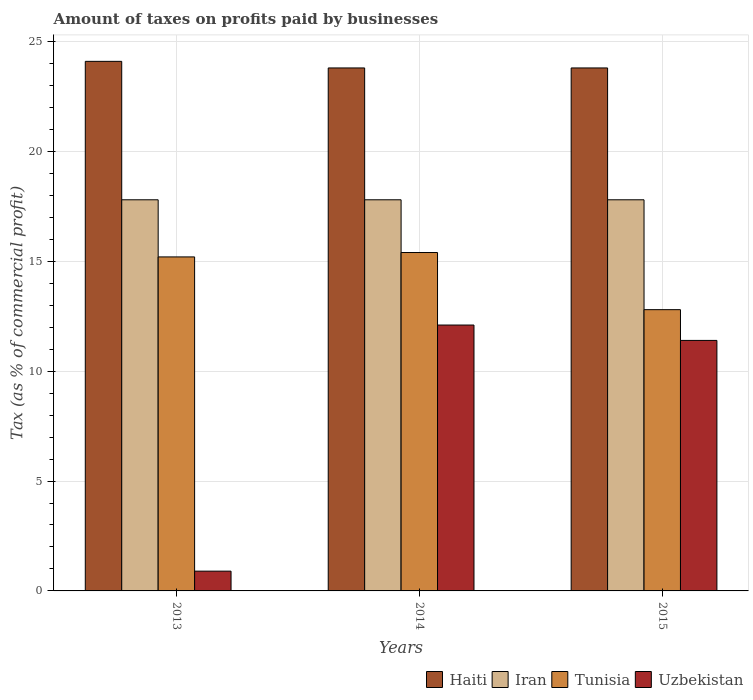How many bars are there on the 1st tick from the left?
Provide a succinct answer. 4. What is the label of the 3rd group of bars from the left?
Your response must be concise. 2015. In how many cases, is the number of bars for a given year not equal to the number of legend labels?
Provide a short and direct response. 0. What is the percentage of taxes paid by businesses in Tunisia in 2013?
Make the answer very short. 15.2. Across all years, what is the maximum percentage of taxes paid by businesses in Haiti?
Offer a terse response. 24.1. In which year was the percentage of taxes paid by businesses in Uzbekistan minimum?
Ensure brevity in your answer.  2013. What is the total percentage of taxes paid by businesses in Haiti in the graph?
Your answer should be very brief. 71.7. What is the difference between the percentage of taxes paid by businesses in Haiti in 2013 and that in 2015?
Make the answer very short. 0.3. What is the difference between the percentage of taxes paid by businesses in Haiti in 2015 and the percentage of taxes paid by businesses in Uzbekistan in 2013?
Your response must be concise. 22.9. In the year 2013, what is the difference between the percentage of taxes paid by businesses in Haiti and percentage of taxes paid by businesses in Uzbekistan?
Provide a short and direct response. 23.2. In how many years, is the percentage of taxes paid by businesses in Haiti greater than 22 %?
Your response must be concise. 3. What is the ratio of the percentage of taxes paid by businesses in Haiti in 2013 to that in 2015?
Your response must be concise. 1.01. What is the difference between the highest and the second highest percentage of taxes paid by businesses in Haiti?
Your answer should be very brief. 0.3. What is the difference between the highest and the lowest percentage of taxes paid by businesses in Tunisia?
Your answer should be very brief. 2.6. What does the 2nd bar from the left in 2013 represents?
Your response must be concise. Iran. What does the 4th bar from the right in 2014 represents?
Give a very brief answer. Haiti. Is it the case that in every year, the sum of the percentage of taxes paid by businesses in Iran and percentage of taxes paid by businesses in Tunisia is greater than the percentage of taxes paid by businesses in Haiti?
Offer a terse response. Yes. How many years are there in the graph?
Make the answer very short. 3. What is the difference between two consecutive major ticks on the Y-axis?
Your answer should be compact. 5. Does the graph contain grids?
Keep it short and to the point. Yes. Where does the legend appear in the graph?
Make the answer very short. Bottom right. How are the legend labels stacked?
Your answer should be very brief. Horizontal. What is the title of the graph?
Give a very brief answer. Amount of taxes on profits paid by businesses. What is the label or title of the Y-axis?
Your answer should be very brief. Tax (as % of commercial profit). What is the Tax (as % of commercial profit) of Haiti in 2013?
Offer a terse response. 24.1. What is the Tax (as % of commercial profit) in Iran in 2013?
Give a very brief answer. 17.8. What is the Tax (as % of commercial profit) of Tunisia in 2013?
Ensure brevity in your answer.  15.2. What is the Tax (as % of commercial profit) in Uzbekistan in 2013?
Give a very brief answer. 0.9. What is the Tax (as % of commercial profit) in Haiti in 2014?
Offer a terse response. 23.8. What is the Tax (as % of commercial profit) in Tunisia in 2014?
Offer a very short reply. 15.4. What is the Tax (as % of commercial profit) of Haiti in 2015?
Keep it short and to the point. 23.8. Across all years, what is the maximum Tax (as % of commercial profit) of Haiti?
Your answer should be very brief. 24.1. Across all years, what is the maximum Tax (as % of commercial profit) in Tunisia?
Your answer should be compact. 15.4. Across all years, what is the minimum Tax (as % of commercial profit) in Haiti?
Offer a very short reply. 23.8. Across all years, what is the minimum Tax (as % of commercial profit) of Uzbekistan?
Offer a terse response. 0.9. What is the total Tax (as % of commercial profit) of Haiti in the graph?
Your answer should be very brief. 71.7. What is the total Tax (as % of commercial profit) in Iran in the graph?
Your answer should be compact. 53.4. What is the total Tax (as % of commercial profit) in Tunisia in the graph?
Offer a very short reply. 43.4. What is the total Tax (as % of commercial profit) in Uzbekistan in the graph?
Offer a terse response. 24.4. What is the difference between the Tax (as % of commercial profit) in Uzbekistan in 2013 and that in 2014?
Offer a very short reply. -11.2. What is the difference between the Tax (as % of commercial profit) in Haiti in 2013 and that in 2015?
Your response must be concise. 0.3. What is the difference between the Tax (as % of commercial profit) of Iran in 2013 and that in 2015?
Your answer should be compact. 0. What is the difference between the Tax (as % of commercial profit) in Uzbekistan in 2013 and that in 2015?
Keep it short and to the point. -10.5. What is the difference between the Tax (as % of commercial profit) in Haiti in 2014 and that in 2015?
Offer a terse response. 0. What is the difference between the Tax (as % of commercial profit) of Tunisia in 2014 and that in 2015?
Ensure brevity in your answer.  2.6. What is the difference between the Tax (as % of commercial profit) in Iran in 2013 and the Tax (as % of commercial profit) in Uzbekistan in 2014?
Your response must be concise. 5.7. What is the difference between the Tax (as % of commercial profit) in Tunisia in 2013 and the Tax (as % of commercial profit) in Uzbekistan in 2014?
Keep it short and to the point. 3.1. What is the difference between the Tax (as % of commercial profit) in Haiti in 2013 and the Tax (as % of commercial profit) in Uzbekistan in 2015?
Your answer should be compact. 12.7. What is the difference between the Tax (as % of commercial profit) of Iran in 2013 and the Tax (as % of commercial profit) of Tunisia in 2015?
Your answer should be compact. 5. What is the difference between the Tax (as % of commercial profit) in Tunisia in 2013 and the Tax (as % of commercial profit) in Uzbekistan in 2015?
Your answer should be very brief. 3.8. What is the difference between the Tax (as % of commercial profit) in Haiti in 2014 and the Tax (as % of commercial profit) in Tunisia in 2015?
Provide a succinct answer. 11. What is the difference between the Tax (as % of commercial profit) in Haiti in 2014 and the Tax (as % of commercial profit) in Uzbekistan in 2015?
Provide a succinct answer. 12.4. What is the difference between the Tax (as % of commercial profit) in Iran in 2014 and the Tax (as % of commercial profit) in Uzbekistan in 2015?
Your answer should be very brief. 6.4. What is the average Tax (as % of commercial profit) of Haiti per year?
Offer a terse response. 23.9. What is the average Tax (as % of commercial profit) in Tunisia per year?
Your response must be concise. 14.47. What is the average Tax (as % of commercial profit) in Uzbekistan per year?
Your response must be concise. 8.13. In the year 2013, what is the difference between the Tax (as % of commercial profit) of Haiti and Tax (as % of commercial profit) of Tunisia?
Provide a succinct answer. 8.9. In the year 2013, what is the difference between the Tax (as % of commercial profit) in Haiti and Tax (as % of commercial profit) in Uzbekistan?
Ensure brevity in your answer.  23.2. In the year 2013, what is the difference between the Tax (as % of commercial profit) of Iran and Tax (as % of commercial profit) of Uzbekistan?
Provide a short and direct response. 16.9. In the year 2014, what is the difference between the Tax (as % of commercial profit) in Haiti and Tax (as % of commercial profit) in Iran?
Provide a short and direct response. 6. In the year 2014, what is the difference between the Tax (as % of commercial profit) of Haiti and Tax (as % of commercial profit) of Tunisia?
Make the answer very short. 8.4. In the year 2014, what is the difference between the Tax (as % of commercial profit) in Haiti and Tax (as % of commercial profit) in Uzbekistan?
Make the answer very short. 11.7. In the year 2014, what is the difference between the Tax (as % of commercial profit) in Iran and Tax (as % of commercial profit) in Tunisia?
Keep it short and to the point. 2.4. In the year 2014, what is the difference between the Tax (as % of commercial profit) in Tunisia and Tax (as % of commercial profit) in Uzbekistan?
Provide a short and direct response. 3.3. In the year 2015, what is the difference between the Tax (as % of commercial profit) of Haiti and Tax (as % of commercial profit) of Iran?
Ensure brevity in your answer.  6. In the year 2015, what is the difference between the Tax (as % of commercial profit) of Haiti and Tax (as % of commercial profit) of Tunisia?
Your answer should be very brief. 11. In the year 2015, what is the difference between the Tax (as % of commercial profit) in Haiti and Tax (as % of commercial profit) in Uzbekistan?
Offer a very short reply. 12.4. In the year 2015, what is the difference between the Tax (as % of commercial profit) of Iran and Tax (as % of commercial profit) of Uzbekistan?
Offer a very short reply. 6.4. What is the ratio of the Tax (as % of commercial profit) in Haiti in 2013 to that in 2014?
Offer a very short reply. 1.01. What is the ratio of the Tax (as % of commercial profit) in Iran in 2013 to that in 2014?
Give a very brief answer. 1. What is the ratio of the Tax (as % of commercial profit) of Uzbekistan in 2013 to that in 2014?
Offer a terse response. 0.07. What is the ratio of the Tax (as % of commercial profit) in Haiti in 2013 to that in 2015?
Provide a succinct answer. 1.01. What is the ratio of the Tax (as % of commercial profit) in Tunisia in 2013 to that in 2015?
Provide a short and direct response. 1.19. What is the ratio of the Tax (as % of commercial profit) in Uzbekistan in 2013 to that in 2015?
Make the answer very short. 0.08. What is the ratio of the Tax (as % of commercial profit) of Iran in 2014 to that in 2015?
Your response must be concise. 1. What is the ratio of the Tax (as % of commercial profit) in Tunisia in 2014 to that in 2015?
Your response must be concise. 1.2. What is the ratio of the Tax (as % of commercial profit) in Uzbekistan in 2014 to that in 2015?
Your response must be concise. 1.06. What is the difference between the highest and the second highest Tax (as % of commercial profit) of Haiti?
Provide a short and direct response. 0.3. What is the difference between the highest and the second highest Tax (as % of commercial profit) in Iran?
Keep it short and to the point. 0. What is the difference between the highest and the second highest Tax (as % of commercial profit) of Tunisia?
Keep it short and to the point. 0.2. What is the difference between the highest and the lowest Tax (as % of commercial profit) in Haiti?
Your answer should be compact. 0.3. What is the difference between the highest and the lowest Tax (as % of commercial profit) in Iran?
Make the answer very short. 0. What is the difference between the highest and the lowest Tax (as % of commercial profit) in Uzbekistan?
Your response must be concise. 11.2. 